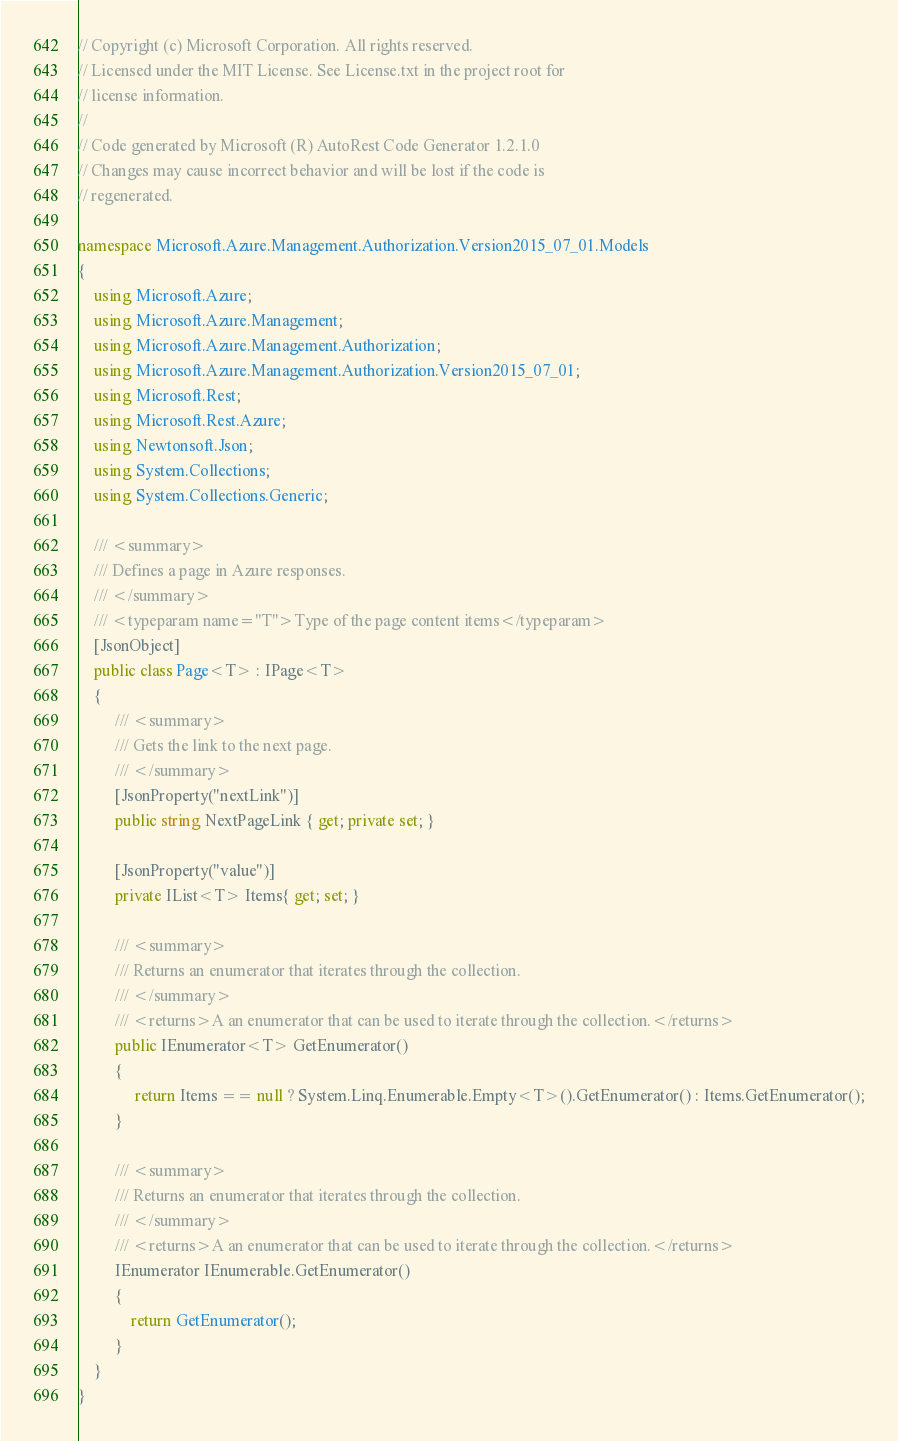Convert code to text. <code><loc_0><loc_0><loc_500><loc_500><_C#_>// Copyright (c) Microsoft Corporation. All rights reserved.
// Licensed under the MIT License. See License.txt in the project root for
// license information.
//
// Code generated by Microsoft (R) AutoRest Code Generator 1.2.1.0
// Changes may cause incorrect behavior and will be lost if the code is
// regenerated.

namespace Microsoft.Azure.Management.Authorization.Version2015_07_01.Models
{
    using Microsoft.Azure;
    using Microsoft.Azure.Management;
    using Microsoft.Azure.Management.Authorization;
    using Microsoft.Azure.Management.Authorization.Version2015_07_01;
    using Microsoft.Rest;
    using Microsoft.Rest.Azure;
    using Newtonsoft.Json;
    using System.Collections;
    using System.Collections.Generic;

    /// <summary>
    /// Defines a page in Azure responses.
    /// </summary>
    /// <typeparam name="T">Type of the page content items</typeparam>
    [JsonObject]
    public class Page<T> : IPage<T>
    {
         /// <summary>
         /// Gets the link to the next page.
         /// </summary>
         [JsonProperty("nextLink")]
         public string NextPageLink { get; private set; }

         [JsonProperty("value")]
         private IList<T> Items{ get; set; }

         /// <summary>
         /// Returns an enumerator that iterates through the collection.
         /// </summary>
         /// <returns>A an enumerator that can be used to iterate through the collection.</returns>
         public IEnumerator<T> GetEnumerator()
         {
              return Items == null ? System.Linq.Enumerable.Empty<T>().GetEnumerator() : Items.GetEnumerator();
         }

         /// <summary>
         /// Returns an enumerator that iterates through the collection.
         /// </summary>
         /// <returns>A an enumerator that can be used to iterate through the collection.</returns>
         IEnumerator IEnumerable.GetEnumerator()
         {
             return GetEnumerator();
         }
    }
}
</code> 